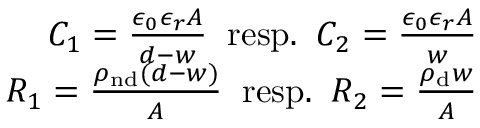Convert formula to latex. <formula><loc_0><loc_0><loc_500><loc_500>\begin{array} { r } { C _ { 1 } = \frac { \epsilon _ { 0 } \epsilon _ { r } A } { d - w } \, r e s p . \, C _ { 2 } = \frac { \epsilon _ { 0 } \epsilon _ { r } A } { w } } \\ { R _ { 1 } = \frac { \rho _ { n d } ( d - w ) } { A } \, r e s p . \, R _ { 2 } = \frac { \rho _ { d } w } { A } } \end{array}</formula> 